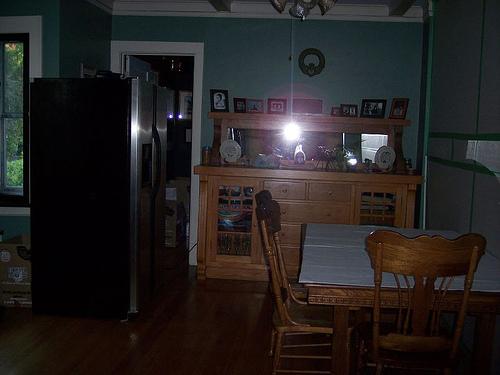Is this a normal sized chair?
Quick response, please. Yes. Is there a painting of van Gogh on one of the chairs?
Answer briefly. No. How many candles are lit?
Short answer required. 0. What color is the fridge?
Short answer required. Black. What is on top of the shelf?
Concise answer only. Pictures. What color are the walls in the picture?
Be succinct. Blue. How many chairs are present?
Write a very short answer. 2. What room is depicted?
Answer briefly. Dining room. IS the clock oddly shaped?
Answer briefly. No. What is leaning against the wall on the back left near the door?
Quick response, please. Picture. What color is the seating?
Give a very brief answer. Brown. What type of chairs are these?
Short answer required. Wooden. What's on the table?
Give a very brief answer. Tablecloth. Is this a hotel?
Keep it brief. No. What is open on the table?
Answer briefly. Nothing. What room is this?
Short answer required. Kitchen. How many chairs are in the room?
Write a very short answer. 2. Why is the room dark?
Be succinct. No light. Is there a child in the image?
Give a very brief answer. No. What shape is the table top?
Short answer required. Rectangle. Does this chair look to be normal size?
Be succinct. Yes. Are there any fruits on the table?
Give a very brief answer. No. What's on the floor in front of the door?
Answer briefly. Refrigerator. What sits on the chair?
Keep it brief. People. Is the fridge in the kitchen?
Keep it brief. Yes. 